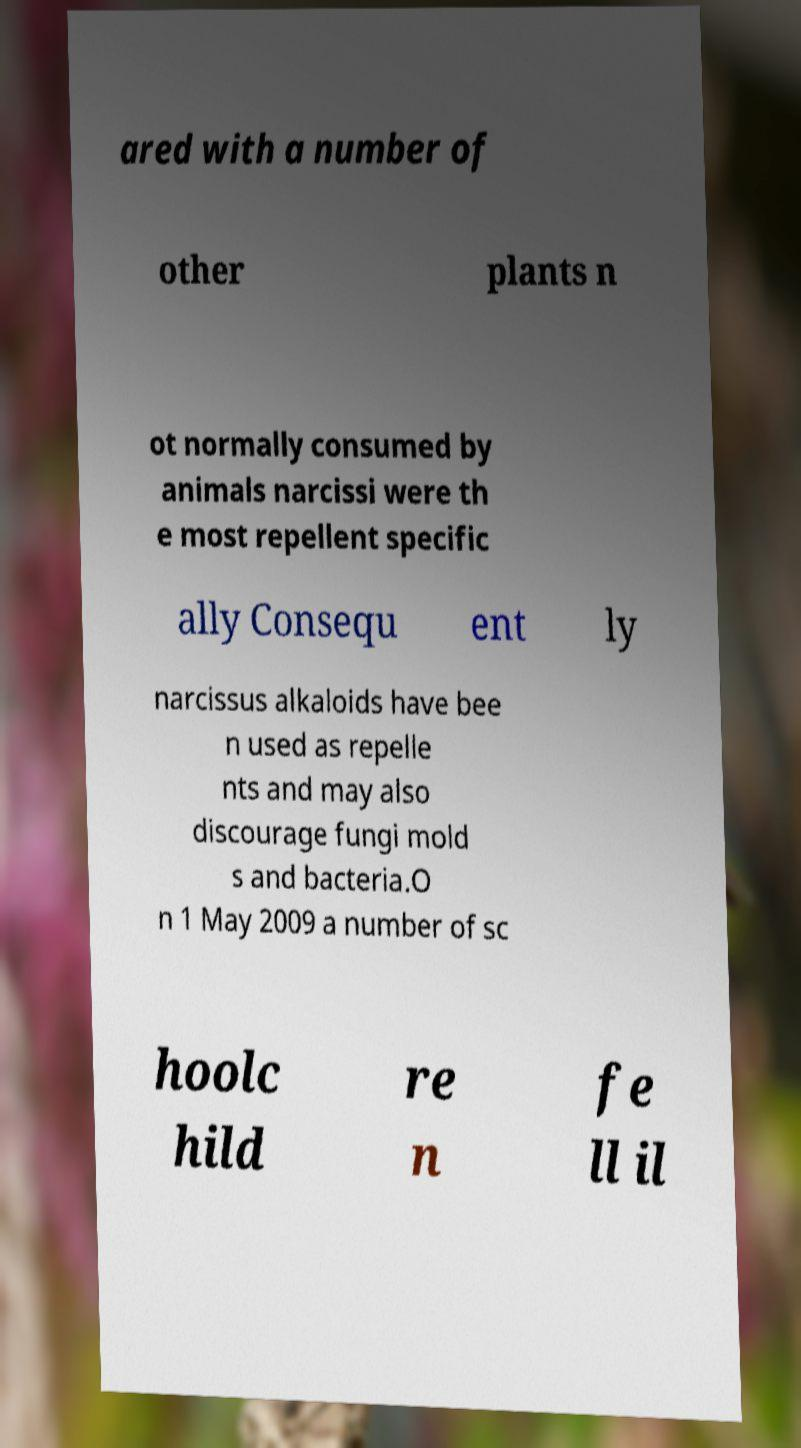There's text embedded in this image that I need extracted. Can you transcribe it verbatim? ared with a number of other plants n ot normally consumed by animals narcissi were th e most repellent specific ally Consequ ent ly narcissus alkaloids have bee n used as repelle nts and may also discourage fungi mold s and bacteria.O n 1 May 2009 a number of sc hoolc hild re n fe ll il 